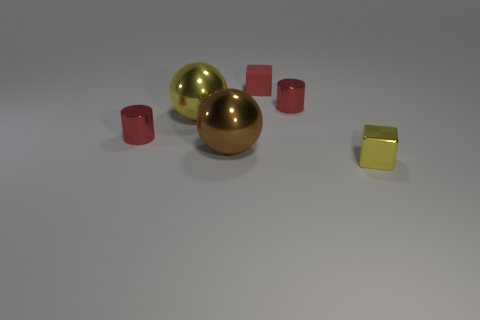Add 4 red spheres. How many objects exist? 10 Subtract all cylinders. How many objects are left? 4 Subtract all yellow blocks. Subtract all big yellow metal objects. How many objects are left? 4 Add 1 small metallic blocks. How many small metallic blocks are left? 2 Add 2 big yellow metallic cylinders. How many big yellow metallic cylinders exist? 2 Subtract 0 green cylinders. How many objects are left? 6 